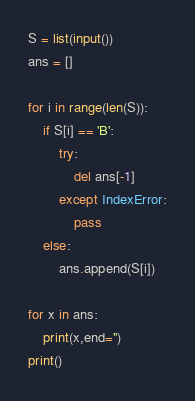<code> <loc_0><loc_0><loc_500><loc_500><_Python_>S = list(input())
ans = []

for i in range(len(S)):
    if S[i] == 'B':
        try:
            del ans[-1]
        except IndexError:
            pass
    else:
        ans.append(S[i])

for x in ans:
    print(x,end='')
print()

</code> 